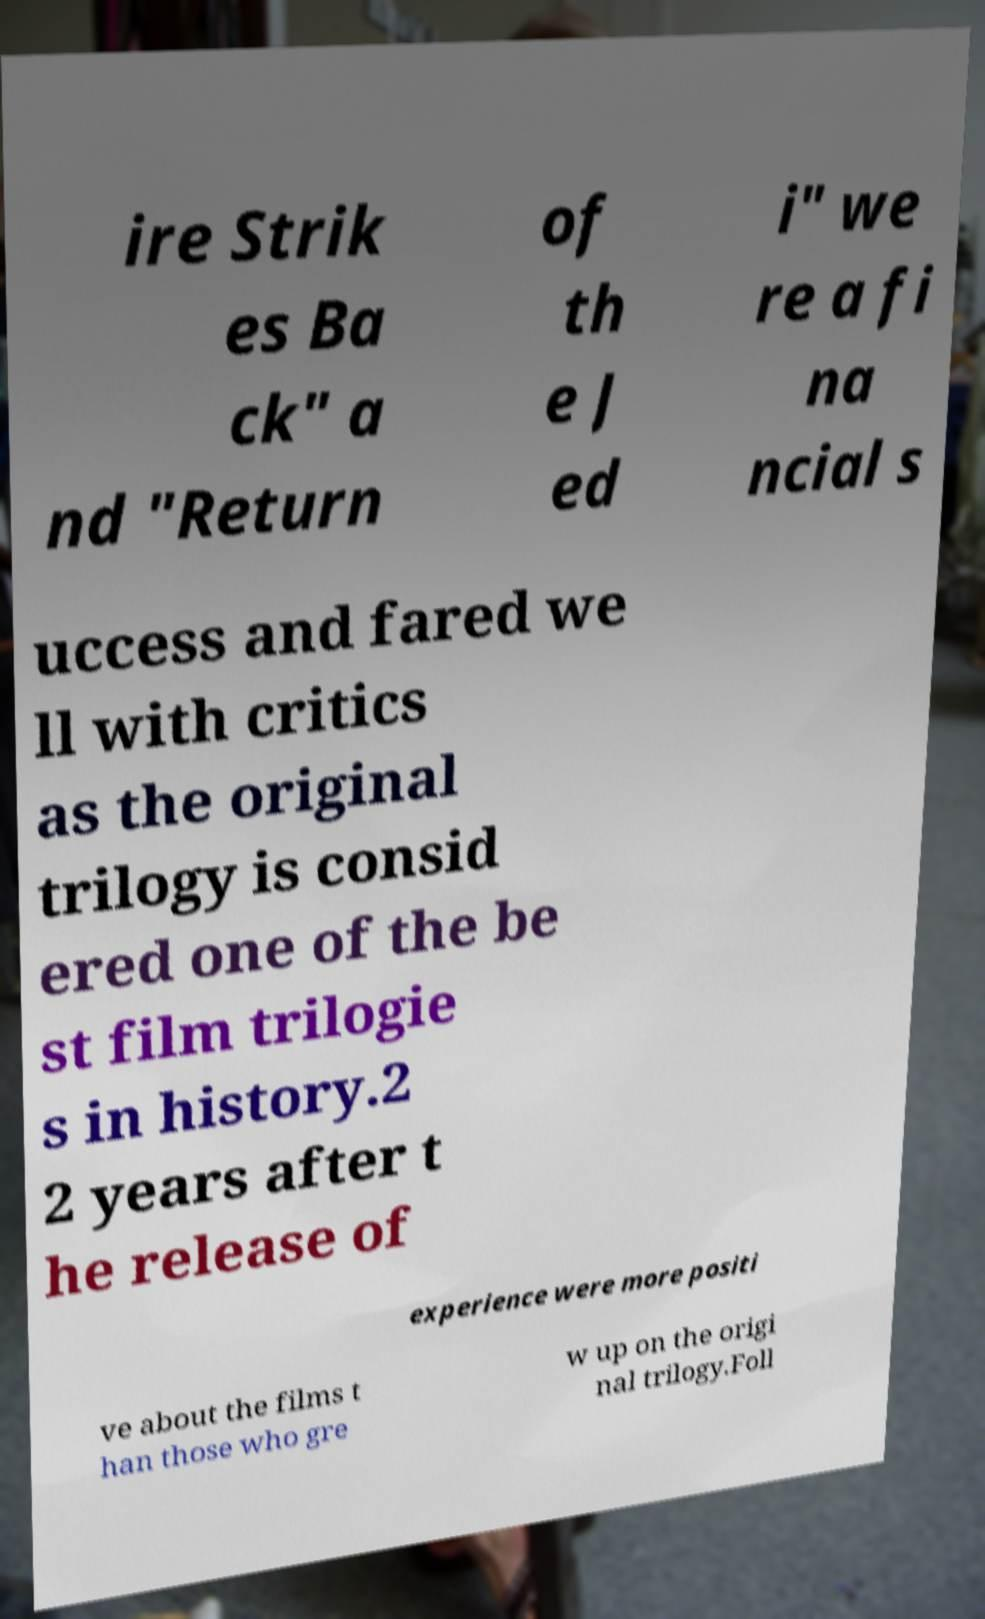Please read and relay the text visible in this image. What does it say? ire Strik es Ba ck" a nd "Return of th e J ed i" we re a fi na ncial s uccess and fared we ll with critics as the original trilogy is consid ered one of the be st film trilogie s in history.2 2 years after t he release of experience were more positi ve about the films t han those who gre w up on the origi nal trilogy.Foll 